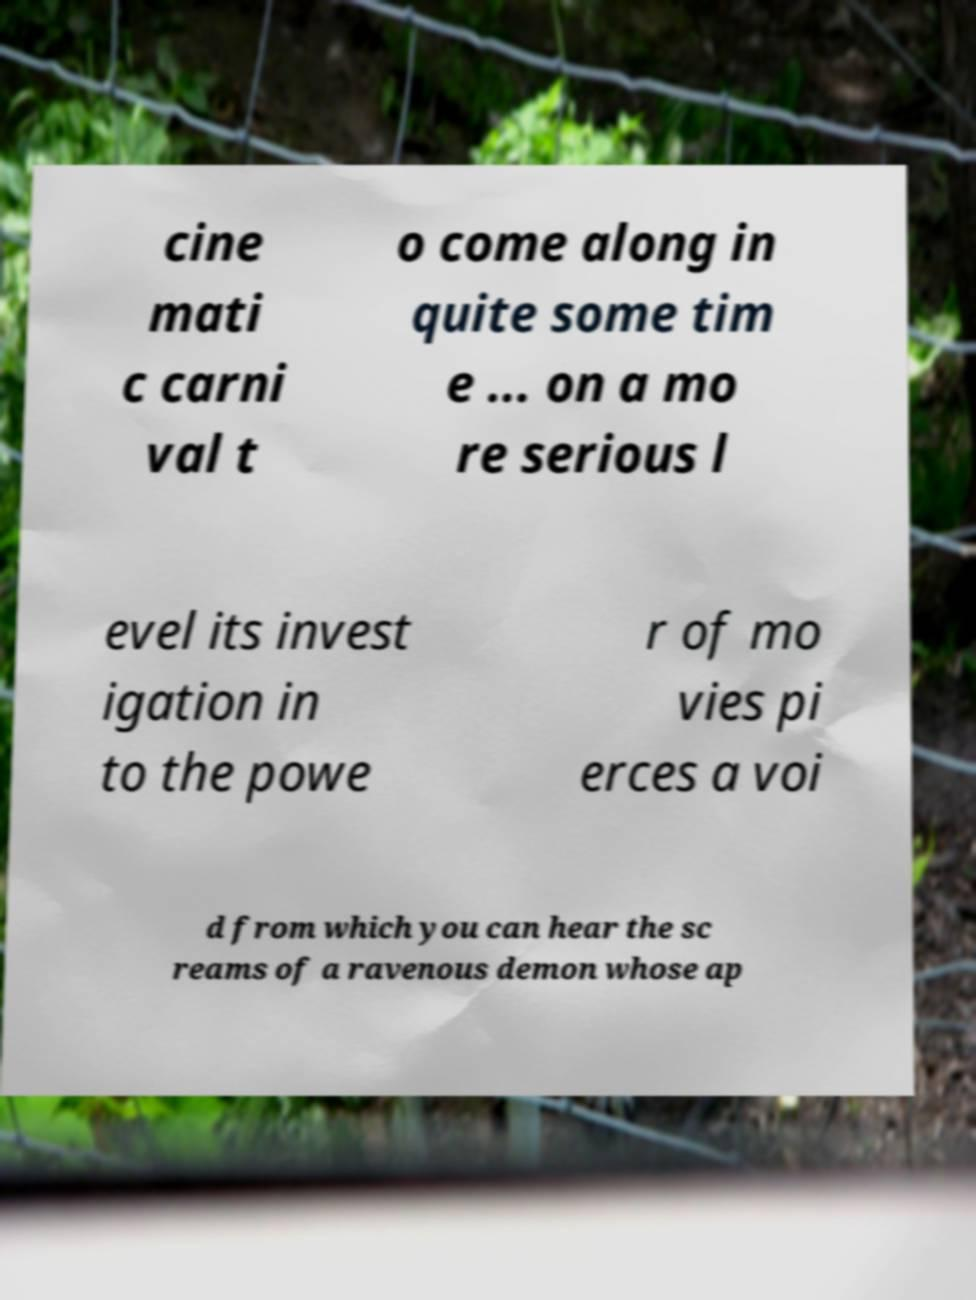What messages or text are displayed in this image? I need them in a readable, typed format. cine mati c carni val t o come along in quite some tim e ... on a mo re serious l evel its invest igation in to the powe r of mo vies pi erces a voi d from which you can hear the sc reams of a ravenous demon whose ap 